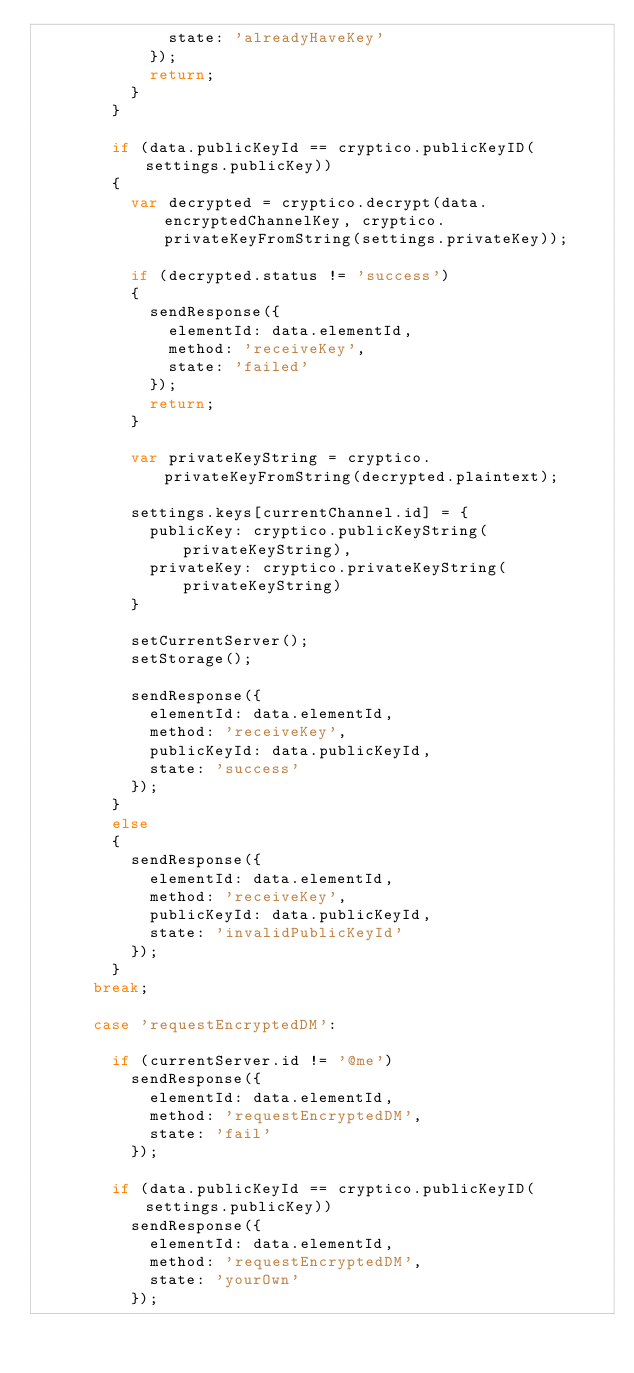<code> <loc_0><loc_0><loc_500><loc_500><_JavaScript_>              state: 'alreadyHaveKey'
            });
            return;
          }
        }

        if (data.publicKeyId == cryptico.publicKeyID(settings.publicKey))
        {
          var decrypted = cryptico.decrypt(data.encryptedChannelKey, cryptico.privateKeyFromString(settings.privateKey));

          if (decrypted.status != 'success')
          {
            sendResponse({
              elementId: data.elementId,
              method: 'receiveKey',
              state: 'failed'
            });
            return;
          }

          var privateKeyString = cryptico.privateKeyFromString(decrypted.plaintext);

          settings.keys[currentChannel.id] = {
            publicKey: cryptico.publicKeyString(privateKeyString),
            privateKey: cryptico.privateKeyString(privateKeyString)
          }

          setCurrentServer();
          setStorage();

          sendResponse({
            elementId: data.elementId,
            method: 'receiveKey',
            publicKeyId: data.publicKeyId,
            state: 'success'
          });
        }
        else
        {
          sendResponse({
            elementId: data.elementId,
            method: 'receiveKey',
            publicKeyId: data.publicKeyId,
            state: 'invalidPublicKeyId'
          });
        }
      break;

      case 'requestEncryptedDM':

        if (currentServer.id != '@me')
          sendResponse({
            elementId: data.elementId,
            method: 'requestEncryptedDM',
            state: 'fail'
          });

        if (data.publicKeyId == cryptico.publicKeyID(settings.publicKey))
          sendResponse({
            elementId: data.elementId,
            method: 'requestEncryptedDM',
            state: 'yourOwn'
          });
</code> 